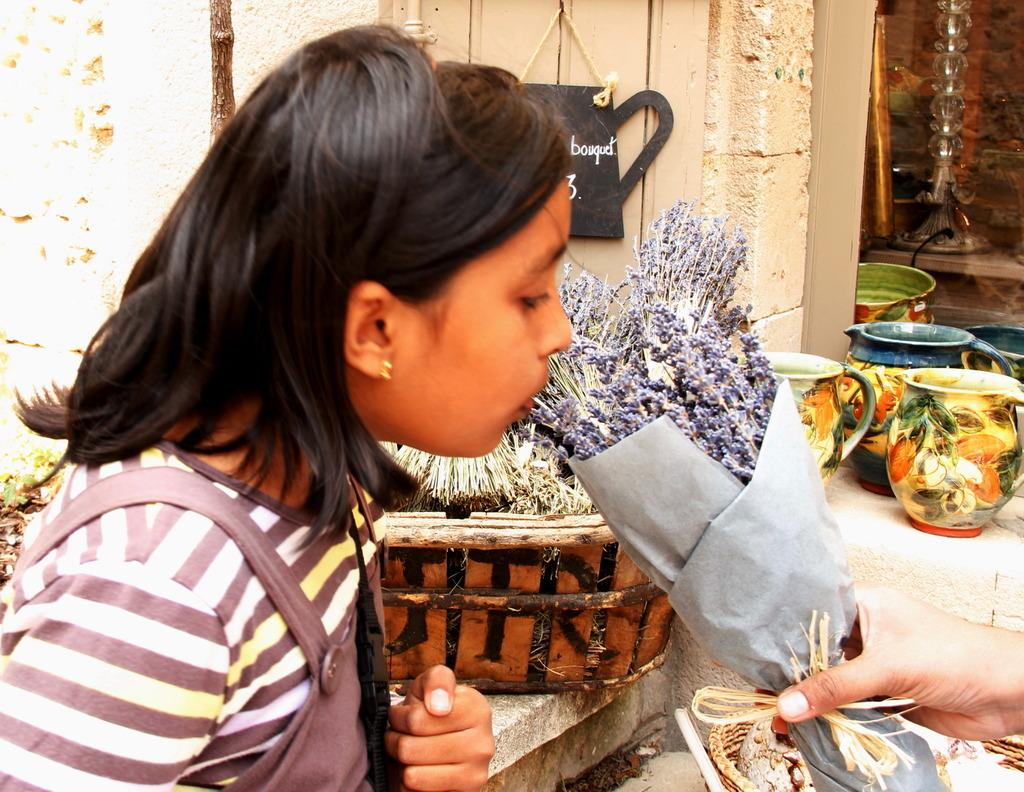Who is the main subject in the image? There is a girl in the image. What is the girl doing in the image? The girl is smelling flowers. Can you describe the person next to the girl? The person is holding a flower bouquet. What type of containers are visible in the image? There are jugs in the image. What is another object present in the image? There is a basket in the image. What type of band is playing in the background of the image? There is no band present in the image; it only features a girl smelling flowers and a person holding a flower bouquet. 